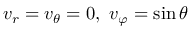<formula> <loc_0><loc_0><loc_500><loc_500>v _ { r } = v _ { \theta } = 0 , v _ { \varphi } = \sin { \theta }</formula> 